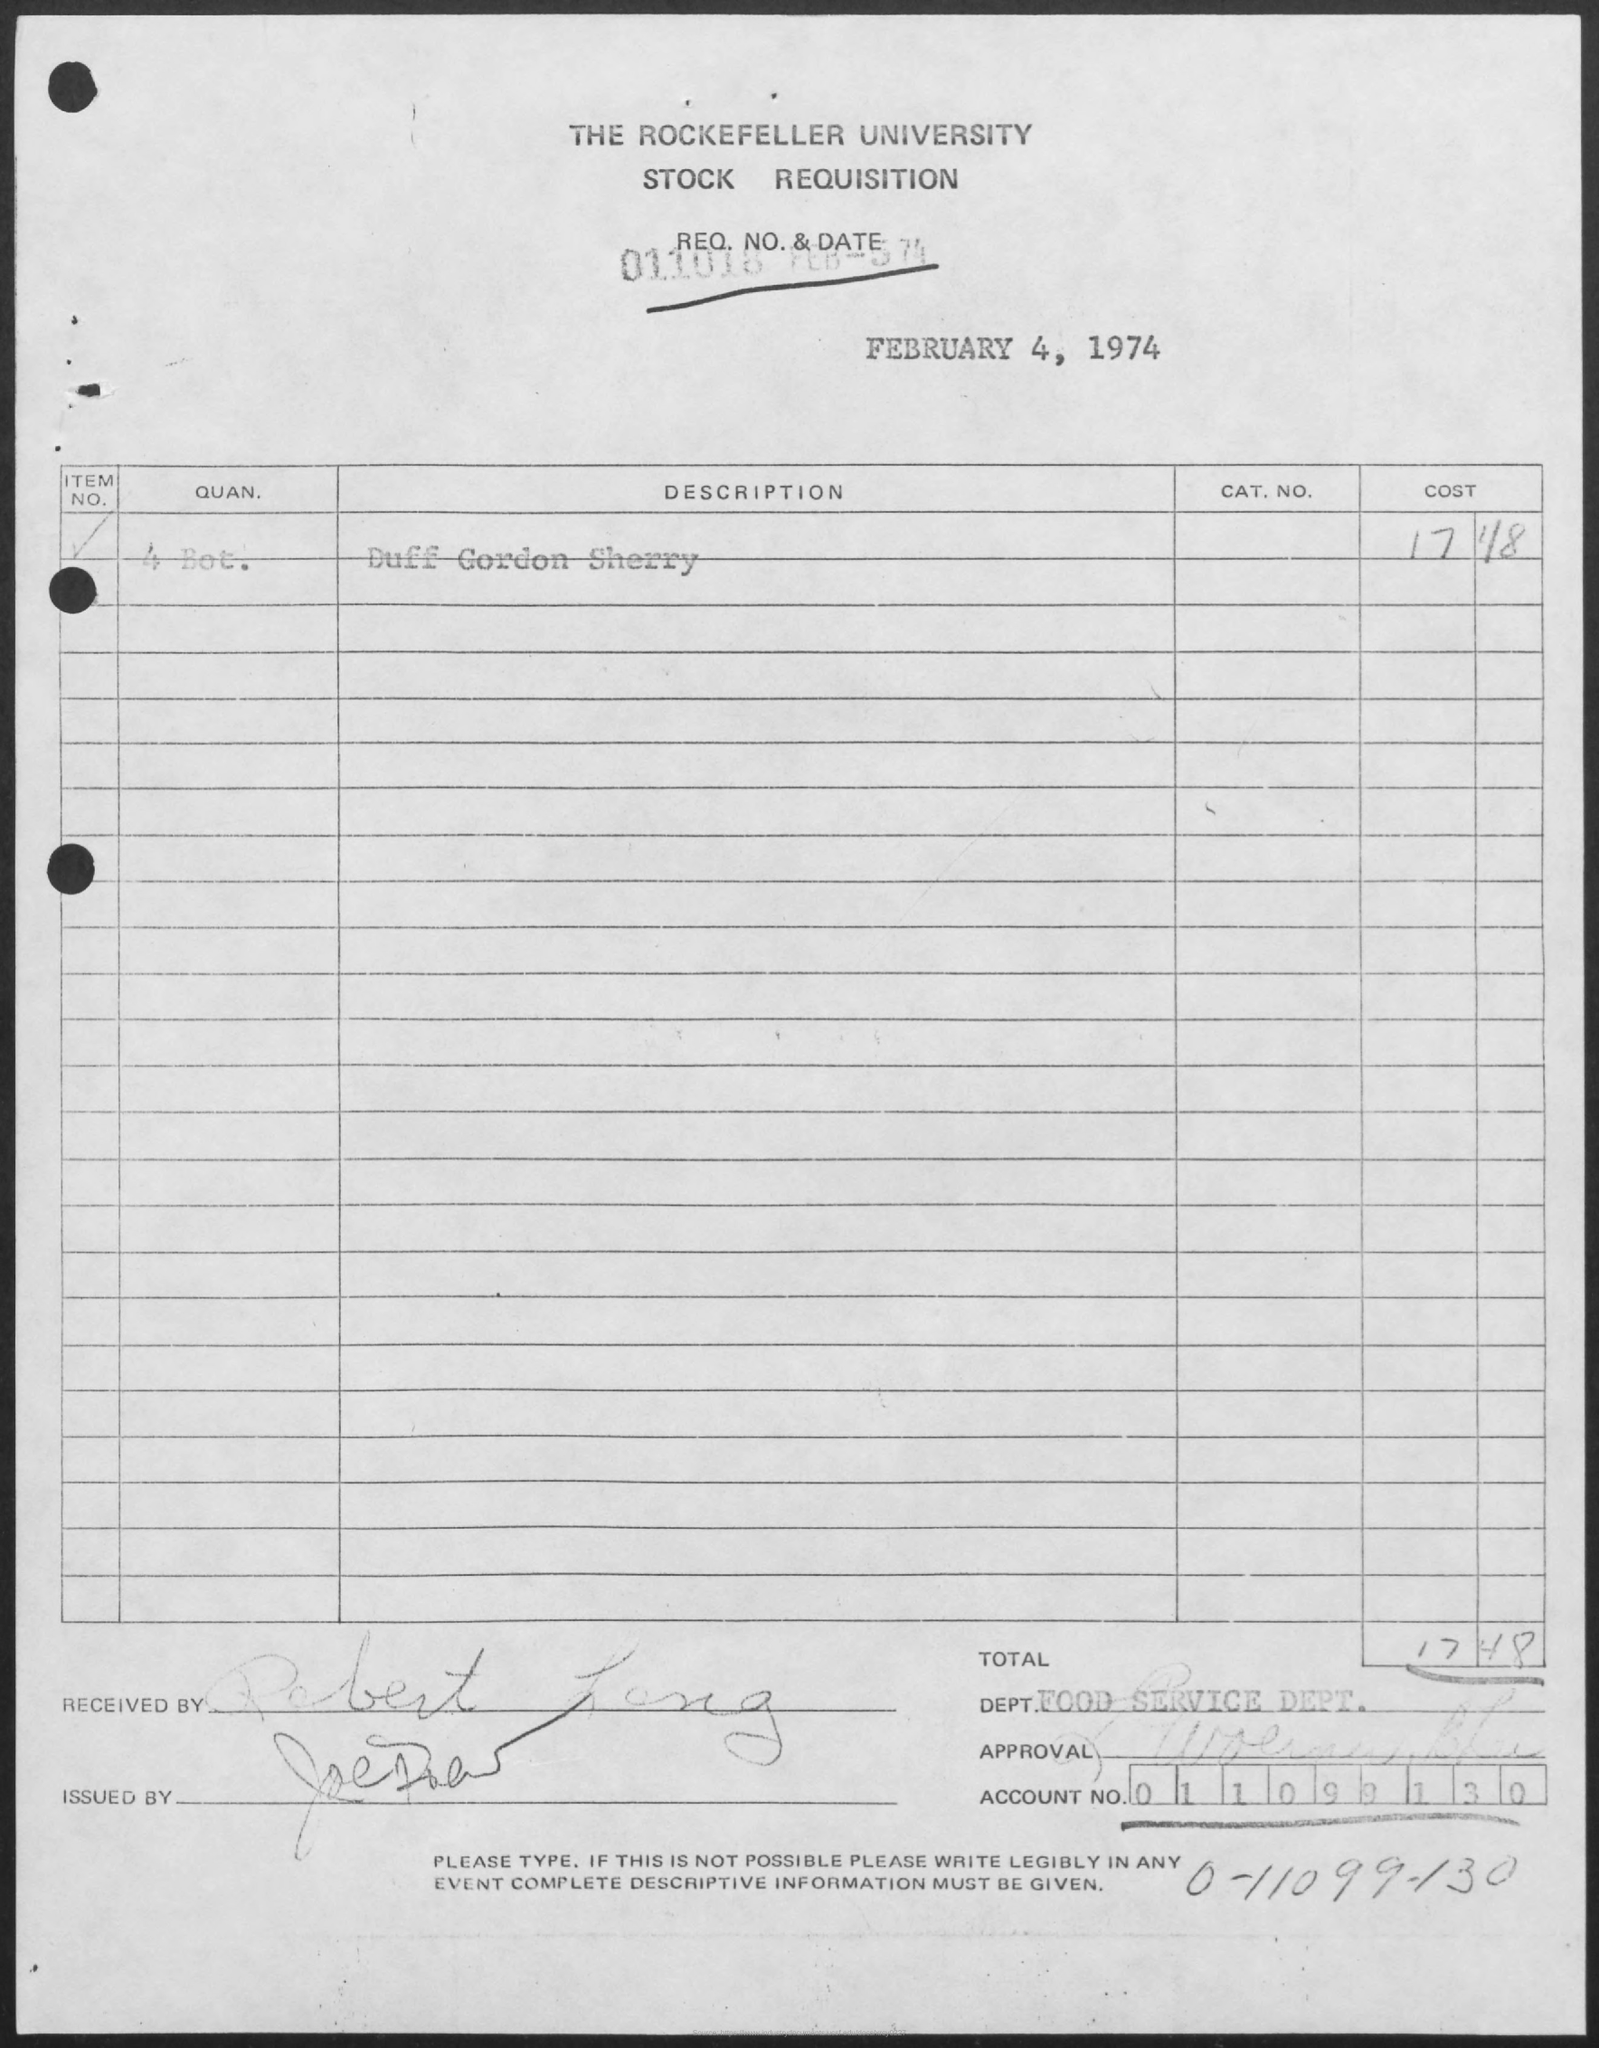What is written in the Letter Head ?
Your answer should be compact. The Rockefeller University Stock Requisition. When is the Memorandum dated on ?
Offer a very short reply. FEBRUARY 4, 1974. How much Total ?
Ensure brevity in your answer.  17-48. What is the Department Name  ?
Make the answer very short. FOOD SERVICE DEPT. What is the Account Number  ?
Offer a very short reply. 011099130. 